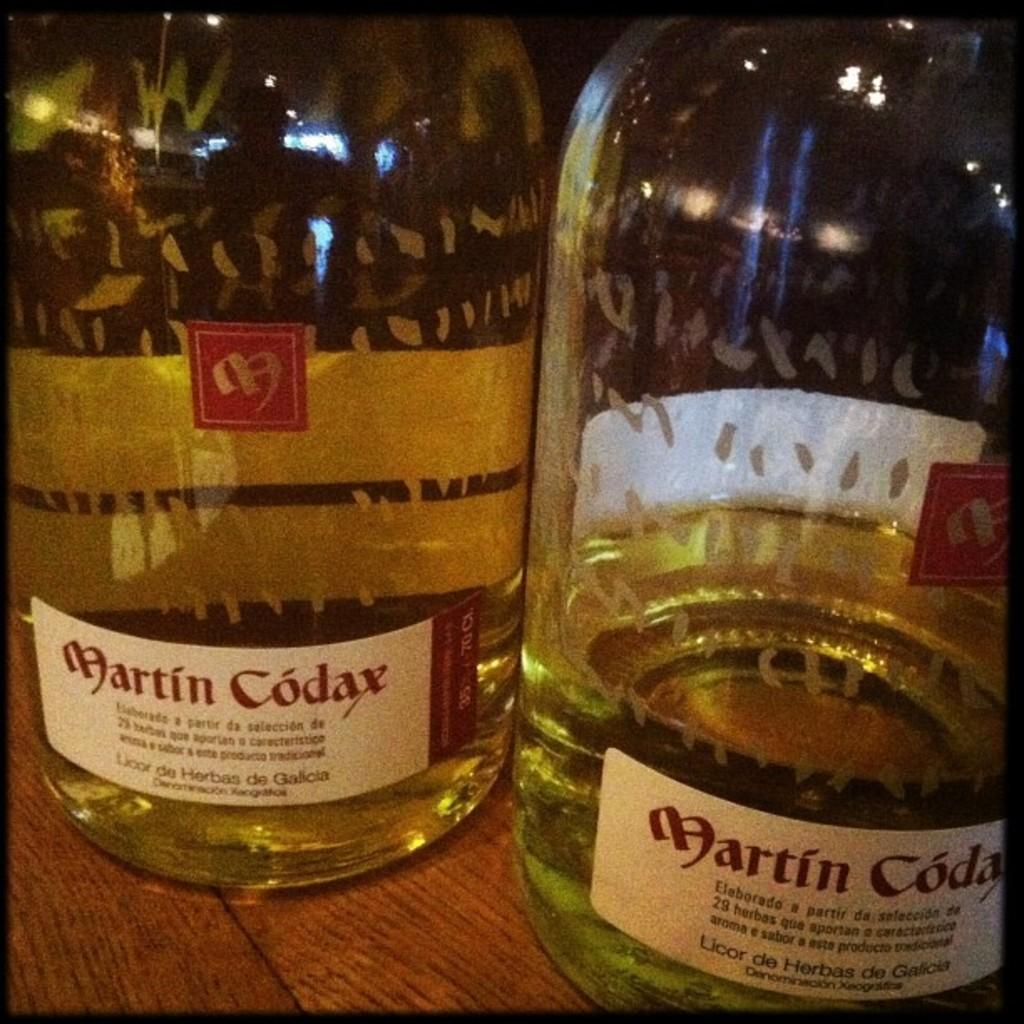How many bottles are on the table in the image? There are two bottles on the table in the image. What is the color of the liquid in one of the bottles? One bottle contains a green liquid. What type of jeans are being worn by the snow in the image? There is no snow or jeans present in the image. 